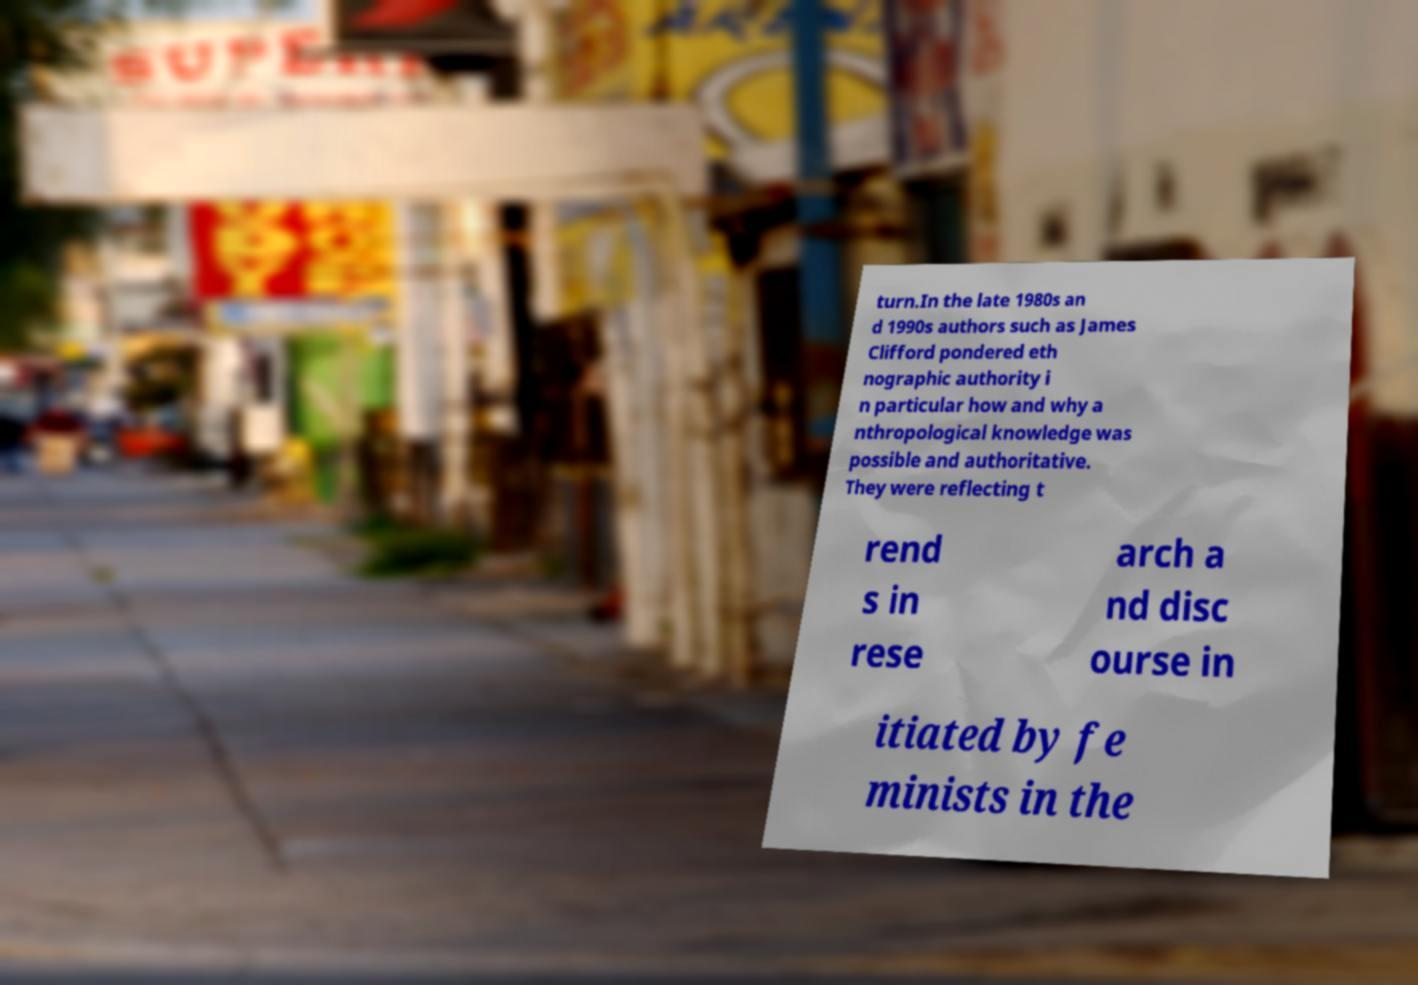Please read and relay the text visible in this image. What does it say? turn.In the late 1980s an d 1990s authors such as James Clifford pondered eth nographic authority i n particular how and why a nthropological knowledge was possible and authoritative. They were reflecting t rend s in rese arch a nd disc ourse in itiated by fe minists in the 